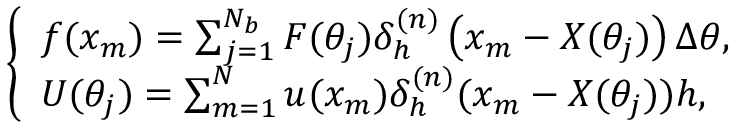Convert formula to latex. <formula><loc_0><loc_0><loc_500><loc_500>\left \{ \begin{array} { l } { f ( x _ { m } ) = \sum _ { j = 1 } ^ { N _ { b } } F ( \theta _ { j } ) \delta _ { h } ^ { ( n ) } \left ( x _ { m } - X ( \theta _ { j } ) \right ) \Delta \theta , } \\ { U ( \theta _ { j } ) = \sum _ { m = 1 } ^ { N } u ( x _ { m } ) \delta _ { h } ^ { ( n ) } ( x _ { m } - X ( \theta _ { j } ) ) h , } \end{array}</formula> 